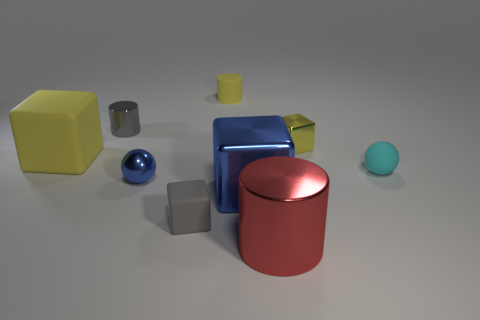Subtract all red cylinders. How many cylinders are left? 2 Subtract 4 blocks. How many blocks are left? 0 Subtract all gray blocks. How many blocks are left? 3 Add 1 yellow cylinders. How many objects exist? 10 Subtract all blocks. How many objects are left? 5 Add 1 large metallic cubes. How many large metallic cubes exist? 2 Subtract 1 blue spheres. How many objects are left? 8 Subtract all purple balls. Subtract all blue blocks. How many balls are left? 2 Subtract all red cylinders. How many gray blocks are left? 1 Subtract all large yellow blocks. Subtract all yellow metal objects. How many objects are left? 7 